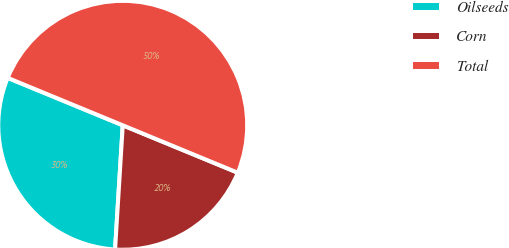Convert chart to OTSL. <chart><loc_0><loc_0><loc_500><loc_500><pie_chart><fcel>Oilseeds<fcel>Corn<fcel>Total<nl><fcel>30.24%<fcel>19.76%<fcel>50.0%<nl></chart> 